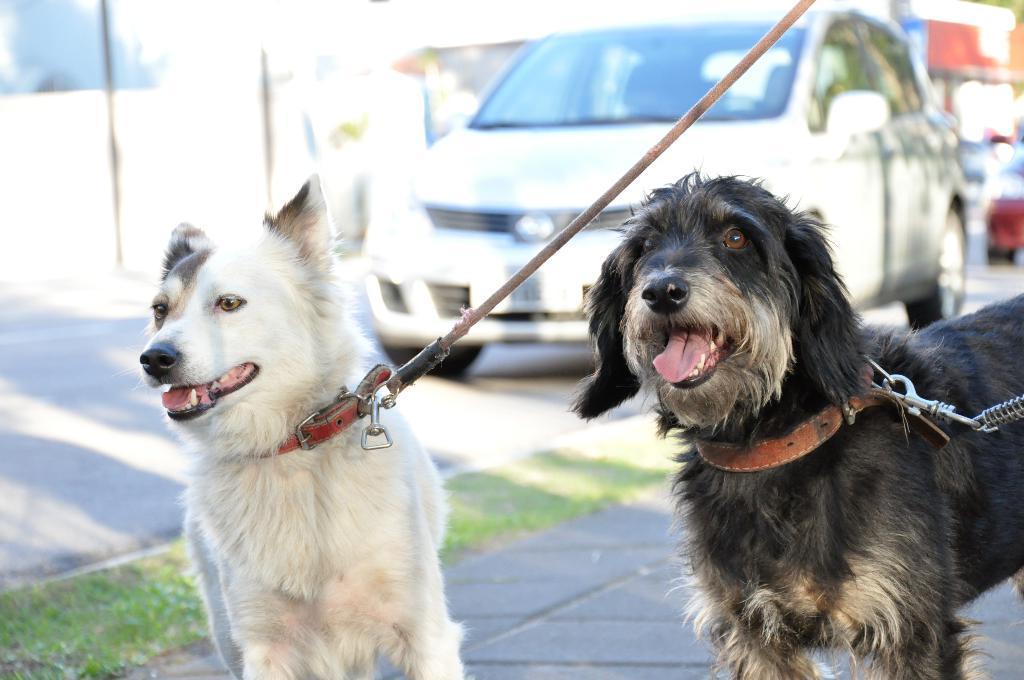In one or two sentences, can you explain what this image depicts? Here we can see dogs with belts. Background it is blurry and we can see car with wheels on the road. 